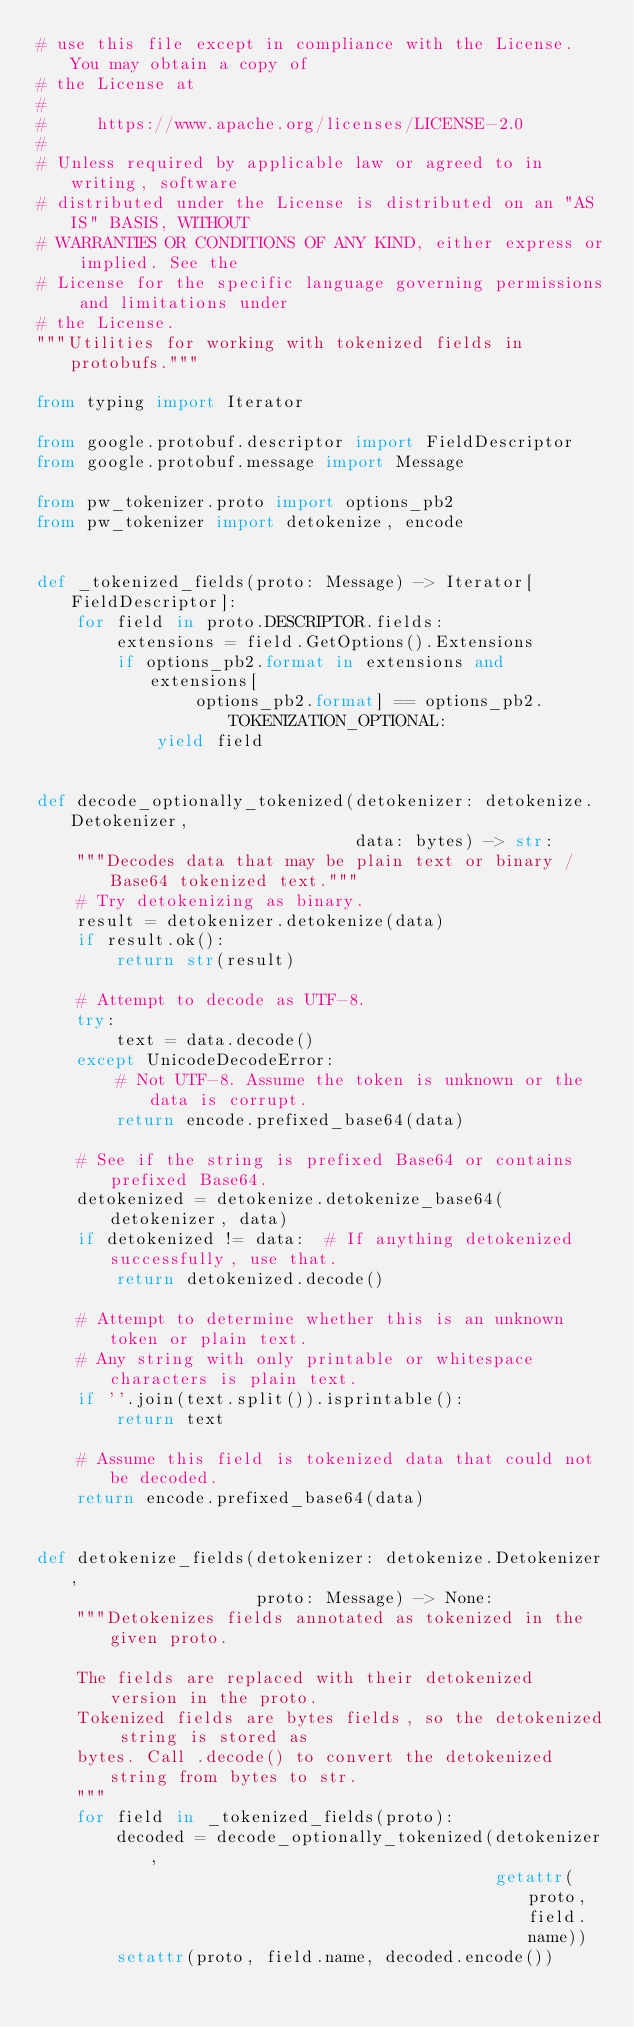Convert code to text. <code><loc_0><loc_0><loc_500><loc_500><_Python_># use this file except in compliance with the License. You may obtain a copy of
# the License at
#
#     https://www.apache.org/licenses/LICENSE-2.0
#
# Unless required by applicable law or agreed to in writing, software
# distributed under the License is distributed on an "AS IS" BASIS, WITHOUT
# WARRANTIES OR CONDITIONS OF ANY KIND, either express or implied. See the
# License for the specific language governing permissions and limitations under
# the License.
"""Utilities for working with tokenized fields in protobufs."""

from typing import Iterator

from google.protobuf.descriptor import FieldDescriptor
from google.protobuf.message import Message

from pw_tokenizer.proto import options_pb2
from pw_tokenizer import detokenize, encode


def _tokenized_fields(proto: Message) -> Iterator[FieldDescriptor]:
    for field in proto.DESCRIPTOR.fields:
        extensions = field.GetOptions().Extensions
        if options_pb2.format in extensions and extensions[
                options_pb2.format] == options_pb2.TOKENIZATION_OPTIONAL:
            yield field


def decode_optionally_tokenized(detokenizer: detokenize.Detokenizer,
                                data: bytes) -> str:
    """Decodes data that may be plain text or binary / Base64 tokenized text."""
    # Try detokenizing as binary.
    result = detokenizer.detokenize(data)
    if result.ok():
        return str(result)

    # Attempt to decode as UTF-8.
    try:
        text = data.decode()
    except UnicodeDecodeError:
        # Not UTF-8. Assume the token is unknown or the data is corrupt.
        return encode.prefixed_base64(data)

    # See if the string is prefixed Base64 or contains prefixed Base64.
    detokenized = detokenize.detokenize_base64(detokenizer, data)
    if detokenized != data:  # If anything detokenized successfully, use that.
        return detokenized.decode()

    # Attempt to determine whether this is an unknown token or plain text.
    # Any string with only printable or whitespace characters is plain text.
    if ''.join(text.split()).isprintable():
        return text

    # Assume this field is tokenized data that could not be decoded.
    return encode.prefixed_base64(data)


def detokenize_fields(detokenizer: detokenize.Detokenizer,
                      proto: Message) -> None:
    """Detokenizes fields annotated as tokenized in the given proto.

    The fields are replaced with their detokenized version in the proto.
    Tokenized fields are bytes fields, so the detokenized string is stored as
    bytes. Call .decode() to convert the detokenized string from bytes to str.
    """
    for field in _tokenized_fields(proto):
        decoded = decode_optionally_tokenized(detokenizer,
                                              getattr(proto, field.name))
        setattr(proto, field.name, decoded.encode())
</code> 